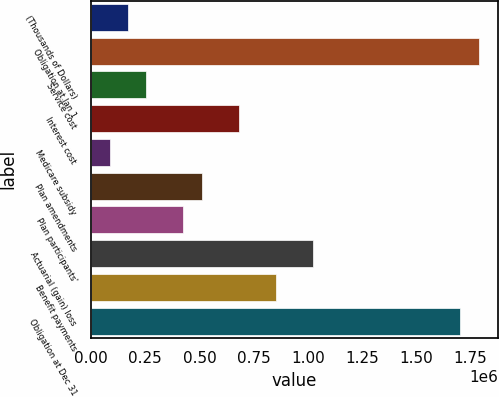<chart> <loc_0><loc_0><loc_500><loc_500><bar_chart><fcel>(Thousands of Dollars)<fcel>Obligation at Jan 1<fcel>Service cost<fcel>Interest cost<fcel>Medicare subsidy<fcel>Plan amendments<fcel>Plan participants'<fcel>Actuarial (gain) loss<fcel>Benefit payments<fcel>Obligation at Dec 31<nl><fcel>170392<fcel>1.7891e+06<fcel>255587<fcel>681562<fcel>85197<fcel>511172<fcel>425977<fcel>1.02234e+06<fcel>851952<fcel>1.7039e+06<nl></chart> 